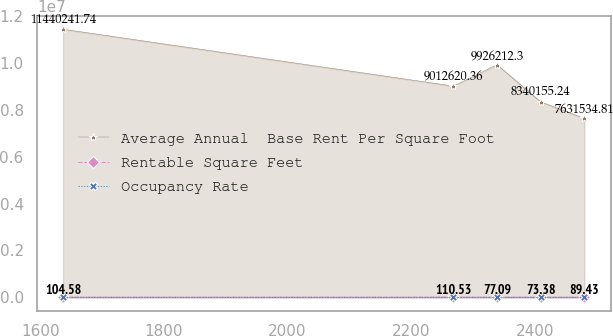<chart> <loc_0><loc_0><loc_500><loc_500><line_chart><ecel><fcel>Average Annual  Base Rent Per Square Foot<fcel>Rentable Square Feet<fcel>Occupancy Rate<nl><fcel>1636.67<fcel>1.14402e+07<fcel>104.58<fcel>13.3<nl><fcel>2268.4<fcel>9.01262e+06<fcel>110.53<fcel>12.21<nl><fcel>2339.06<fcel>9.92621e+06<fcel>77.09<fcel>12.79<nl><fcel>2409.72<fcel>8.34016e+06<fcel>73.38<fcel>12.45<nl><fcel>2480.38<fcel>7.63153e+06<fcel>89.43<fcel>10.9<nl></chart> 